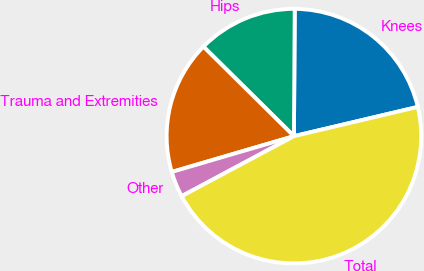Convert chart to OTSL. <chart><loc_0><loc_0><loc_500><loc_500><pie_chart><fcel>Knees<fcel>Hips<fcel>Trauma and Extremities<fcel>Other<fcel>Total<nl><fcel>21.21%<fcel>12.69%<fcel>16.95%<fcel>3.28%<fcel>45.88%<nl></chart> 